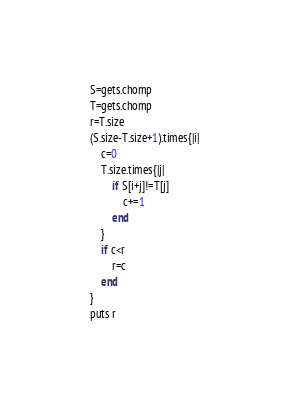<code> <loc_0><loc_0><loc_500><loc_500><_Ruby_>S=gets.chomp
T=gets.chomp
r=T.size
(S.size-T.size+1).times{|i|
    c=0
    T.size.times{|j|
        if S[i+j]!=T[j]
            c+=1
        end
    }
    if c<r
        r=c
    end
}
puts r
</code> 